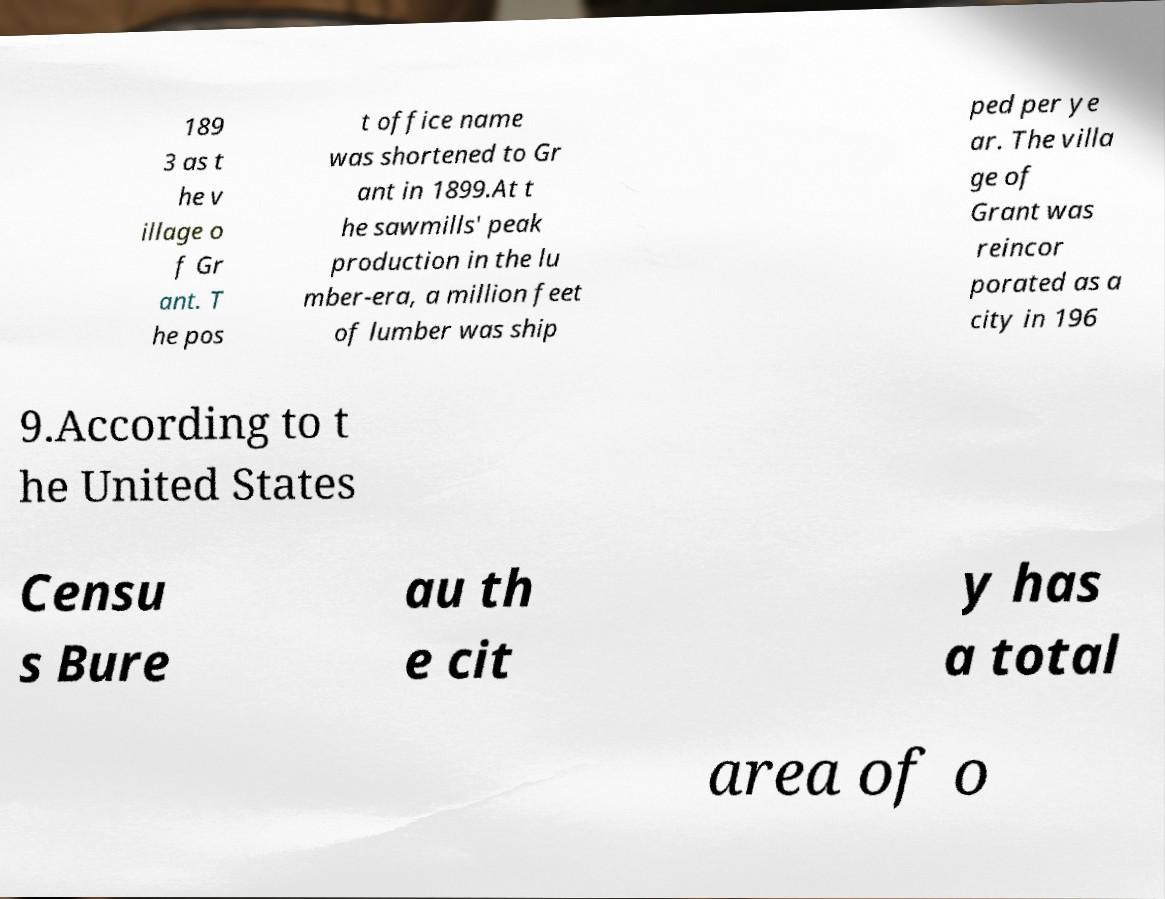There's text embedded in this image that I need extracted. Can you transcribe it verbatim? 189 3 as t he v illage o f Gr ant. T he pos t office name was shortened to Gr ant in 1899.At t he sawmills' peak production in the lu mber-era, a million feet of lumber was ship ped per ye ar. The villa ge of Grant was reincor porated as a city in 196 9.According to t he United States Censu s Bure au th e cit y has a total area of o 